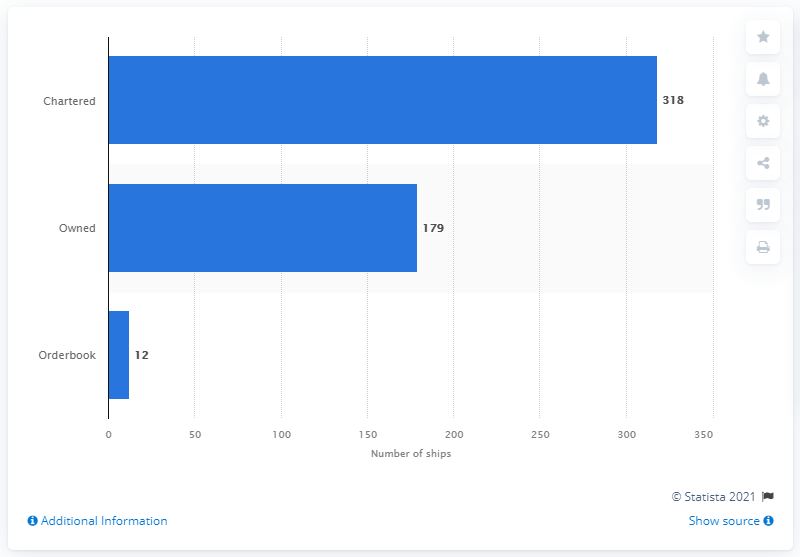Identify some key points in this picture. It is estimated that COSCO owned 179 ships as of [insert date]. 